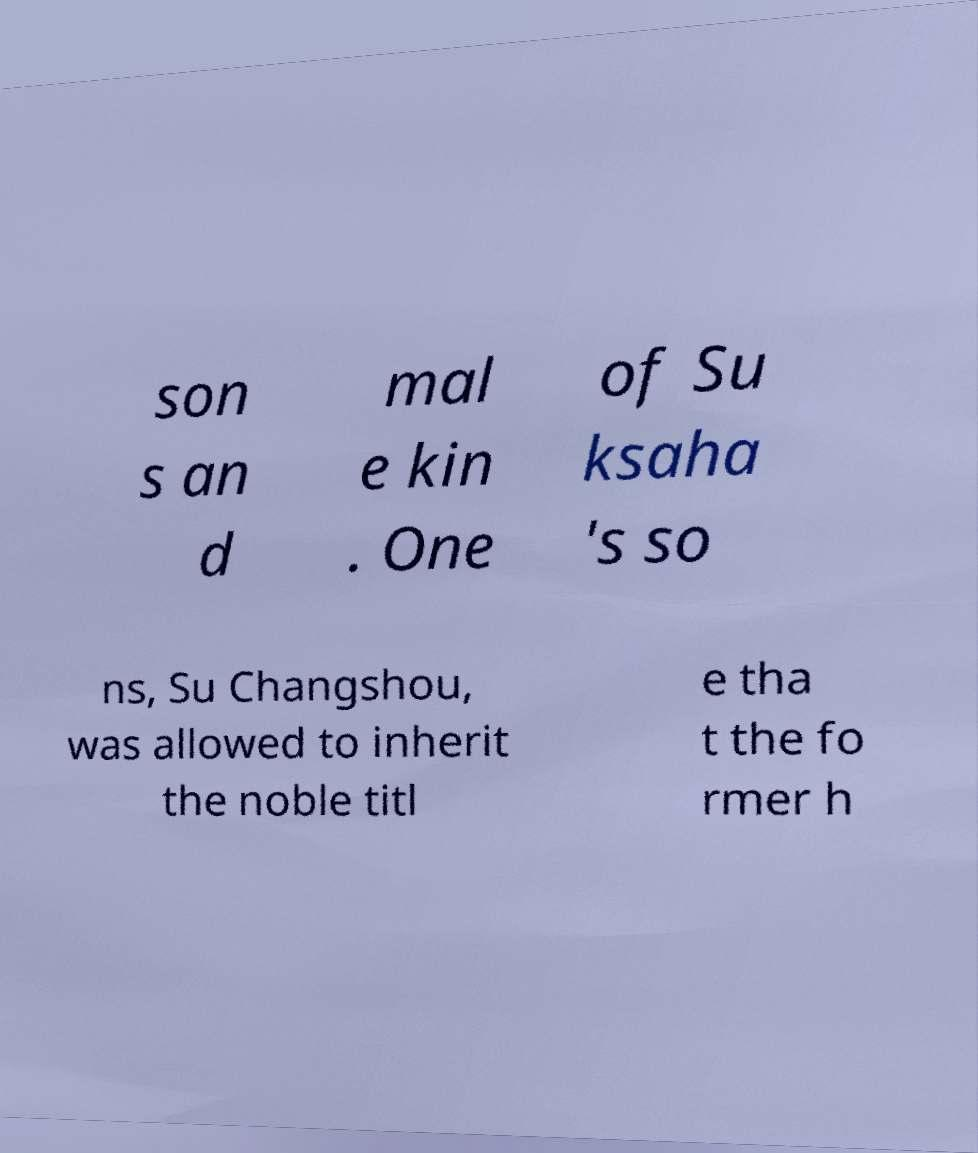Could you assist in decoding the text presented in this image and type it out clearly? son s an d mal e kin . One of Su ksaha 's so ns, Su Changshou, was allowed to inherit the noble titl e tha t the fo rmer h 